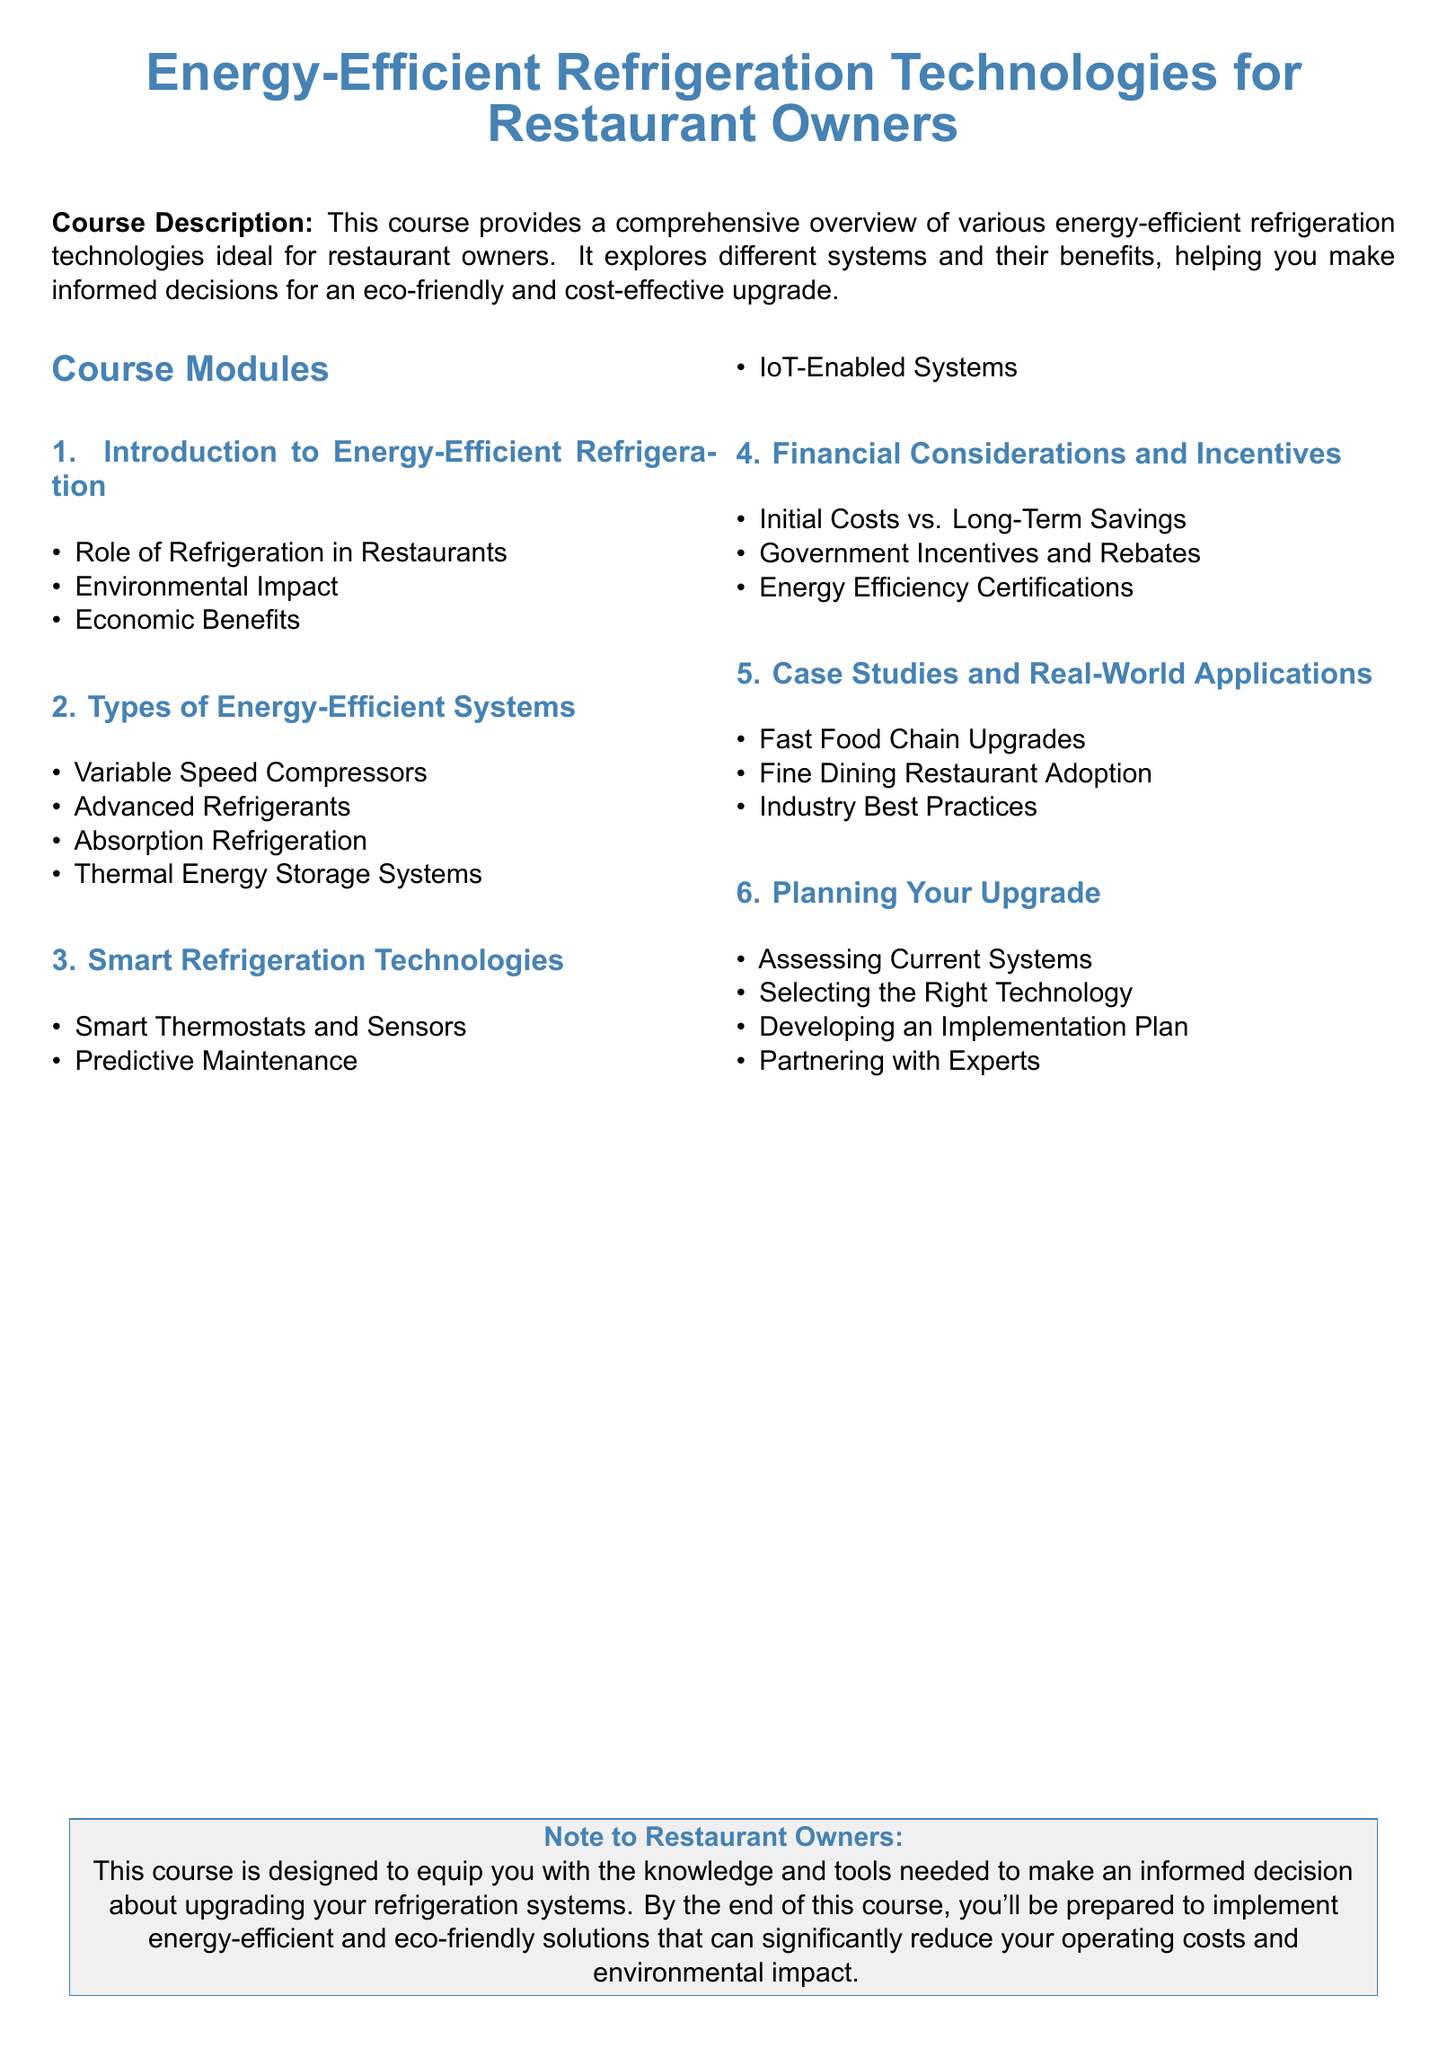What is the course title? The title of the course is presented at the top of the document, indicating the main focus of the syllabus.
Answer: Energy-Efficient Refrigeration Technologies for Restaurant Owners What is covered in Module 2? Module 2 lists specific types of energy-efficient systems relevant to restaurant owners as outlined in the syllabus.
Answer: Types of Energy-Efficient Systems How many subsections are in Module 4? The information regarding the number of subsections in Module 4 can be counted directly from the document structure.
Answer: 3 What technology is mentioned in Module 3? Module 3 lists smart technologies related to refrigeration, one of which is specified in the syllabus.
Answer: Smart Thermostats and Sensors What is an economic benefit discussed in Module 1? The document mentions the economic advantages as one of the key points in Module 1.
Answer: Economic Benefits What is the main focus of Module 6? Module 6 details the planning process for upgrading refrigeration systems, as specified in the syllabus.
Answer: Planning Your Upgrade What type of refrigeration system is noted for its environmental impact? In Module 1, the environmental considerations linked to refrigeration systems are highlighted.
Answer: Environmental Impact What does the course aim to equip restaurant owners with? The document explicitly states the aim of the course regarding knowledge for restaurant owners.
Answer: Knowledge and tools 